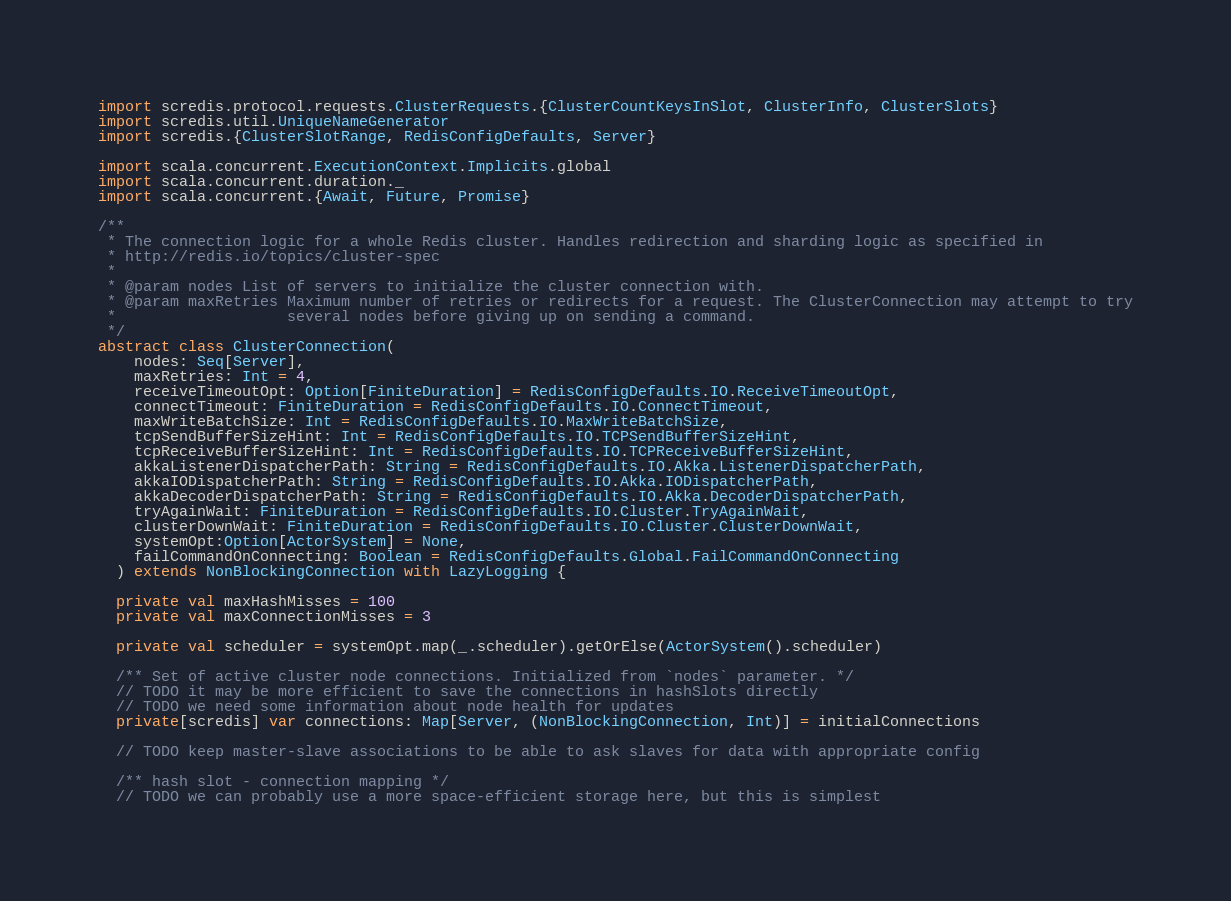Convert code to text. <code><loc_0><loc_0><loc_500><loc_500><_Scala_>import scredis.protocol.requests.ClusterRequests.{ClusterCountKeysInSlot, ClusterInfo, ClusterSlots}
import scredis.util.UniqueNameGenerator
import scredis.{ClusterSlotRange, RedisConfigDefaults, Server}

import scala.concurrent.ExecutionContext.Implicits.global
import scala.concurrent.duration._
import scala.concurrent.{Await, Future, Promise}

/**
 * The connection logic for a whole Redis cluster. Handles redirection and sharding logic as specified in
 * http://redis.io/topics/cluster-spec
 *
 * @param nodes List of servers to initialize the cluster connection with.
 * @param maxRetries Maximum number of retries or redirects for a request. The ClusterConnection may attempt to try
 *                   several nodes before giving up on sending a command.
 */
abstract class ClusterConnection(
    nodes: Seq[Server],
    maxRetries: Int = 4,
    receiveTimeoutOpt: Option[FiniteDuration] = RedisConfigDefaults.IO.ReceiveTimeoutOpt,
    connectTimeout: FiniteDuration = RedisConfigDefaults.IO.ConnectTimeout,
    maxWriteBatchSize: Int = RedisConfigDefaults.IO.MaxWriteBatchSize,
    tcpSendBufferSizeHint: Int = RedisConfigDefaults.IO.TCPSendBufferSizeHint,
    tcpReceiveBufferSizeHint: Int = RedisConfigDefaults.IO.TCPReceiveBufferSizeHint,
    akkaListenerDispatcherPath: String = RedisConfigDefaults.IO.Akka.ListenerDispatcherPath,
    akkaIODispatcherPath: String = RedisConfigDefaults.IO.Akka.IODispatcherPath,
    akkaDecoderDispatcherPath: String = RedisConfigDefaults.IO.Akka.DecoderDispatcherPath,
    tryAgainWait: FiniteDuration = RedisConfigDefaults.IO.Cluster.TryAgainWait,
    clusterDownWait: FiniteDuration = RedisConfigDefaults.IO.Cluster.ClusterDownWait,
    systemOpt:Option[ActorSystem] = None,
    failCommandOnConnecting: Boolean = RedisConfigDefaults.Global.FailCommandOnConnecting
  ) extends NonBlockingConnection with LazyLogging {

  private val maxHashMisses = 100
  private val maxConnectionMisses = 3

  private val scheduler = systemOpt.map(_.scheduler).getOrElse(ActorSystem().scheduler)

  /** Set of active cluster node connections. Initialized from `nodes` parameter. */
  // TODO it may be more efficient to save the connections in hashSlots directly
  // TODO we need some information about node health for updates
  private[scredis] var connections: Map[Server, (NonBlockingConnection, Int)] = initialConnections

  // TODO keep master-slave associations to be able to ask slaves for data with appropriate config

  /** hash slot - connection mapping */
  // TODO we can probably use a more space-efficient storage here, but this is simplest</code> 